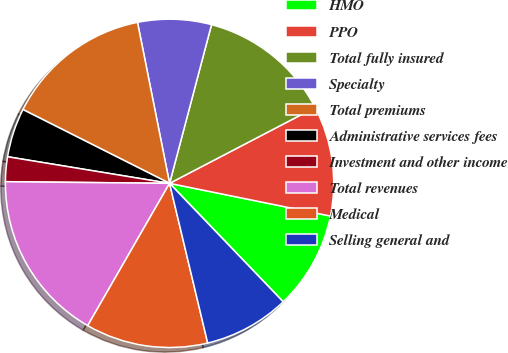Convert chart to OTSL. <chart><loc_0><loc_0><loc_500><loc_500><pie_chart><fcel>HMO<fcel>PPO<fcel>Total fully insured<fcel>Specialty<fcel>Total premiums<fcel>Administrative services fees<fcel>Investment and other income<fcel>Total revenues<fcel>Medical<fcel>Selling general and<nl><fcel>9.64%<fcel>10.84%<fcel>13.24%<fcel>7.24%<fcel>14.45%<fcel>4.83%<fcel>2.43%<fcel>16.85%<fcel>12.04%<fcel>8.44%<nl></chart> 